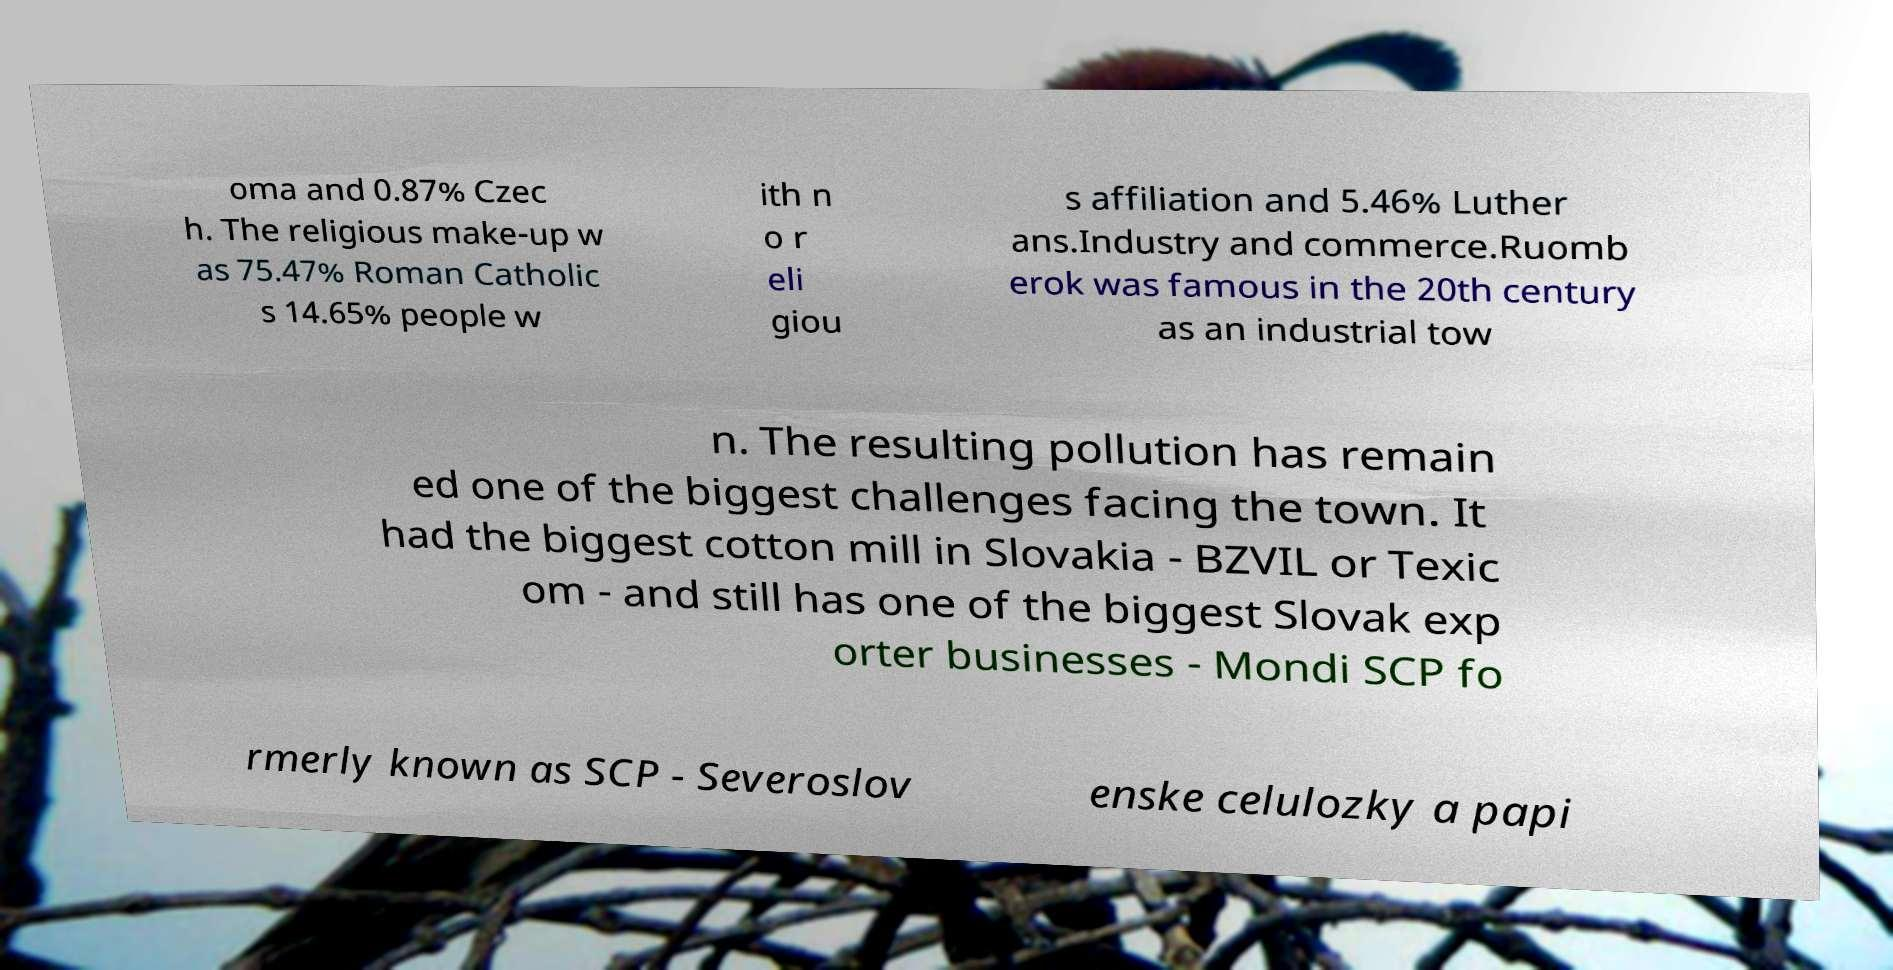Could you assist in decoding the text presented in this image and type it out clearly? oma and 0.87% Czec h. The religious make-up w as 75.47% Roman Catholic s 14.65% people w ith n o r eli giou s affiliation and 5.46% Luther ans.Industry and commerce.Ruomb erok was famous in the 20th century as an industrial tow n. The resulting pollution has remain ed one of the biggest challenges facing the town. It had the biggest cotton mill in Slovakia - BZVIL or Texic om - and still has one of the biggest Slovak exp orter businesses - Mondi SCP fo rmerly known as SCP - Severoslov enske celulozky a papi 